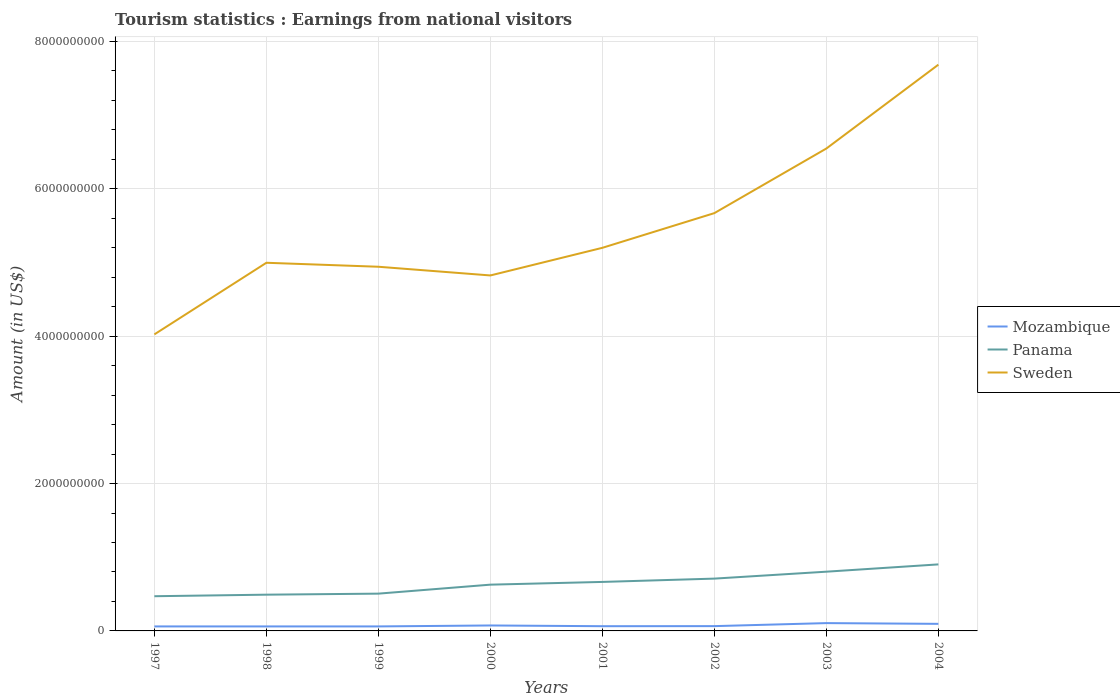Across all years, what is the maximum earnings from national visitors in Sweden?
Provide a short and direct response. 4.02e+09. In which year was the earnings from national visitors in Mozambique maximum?
Offer a terse response. 1997. What is the total earnings from national visitors in Sweden in the graph?
Your response must be concise. -8.46e+08. What is the difference between the highest and the second highest earnings from national visitors in Sweden?
Ensure brevity in your answer.  3.66e+09. What is the difference between the highest and the lowest earnings from national visitors in Mozambique?
Offer a very short reply. 3. How many lines are there?
Offer a very short reply. 3. How many years are there in the graph?
Offer a terse response. 8. Are the values on the major ticks of Y-axis written in scientific E-notation?
Provide a succinct answer. No. Does the graph contain grids?
Offer a terse response. Yes. Where does the legend appear in the graph?
Provide a short and direct response. Center right. How many legend labels are there?
Make the answer very short. 3. What is the title of the graph?
Your answer should be compact. Tourism statistics : Earnings from national visitors. What is the label or title of the Y-axis?
Provide a short and direct response. Amount (in US$). What is the Amount (in US$) in Mozambique in 1997?
Provide a short and direct response. 6.10e+07. What is the Amount (in US$) in Panama in 1997?
Your answer should be compact. 4.71e+08. What is the Amount (in US$) of Sweden in 1997?
Your answer should be very brief. 4.02e+09. What is the Amount (in US$) of Mozambique in 1998?
Provide a short and direct response. 6.10e+07. What is the Amount (in US$) of Panama in 1998?
Keep it short and to the point. 4.92e+08. What is the Amount (in US$) in Sweden in 1998?
Provide a short and direct response. 5.00e+09. What is the Amount (in US$) of Mozambique in 1999?
Provide a short and direct response. 6.10e+07. What is the Amount (in US$) in Panama in 1999?
Give a very brief answer. 5.06e+08. What is the Amount (in US$) of Sweden in 1999?
Provide a succinct answer. 4.94e+09. What is the Amount (in US$) in Mozambique in 2000?
Keep it short and to the point. 7.40e+07. What is the Amount (in US$) of Panama in 2000?
Your answer should be compact. 6.28e+08. What is the Amount (in US$) of Sweden in 2000?
Offer a terse response. 4.82e+09. What is the Amount (in US$) in Mozambique in 2001?
Make the answer very short. 6.40e+07. What is the Amount (in US$) of Panama in 2001?
Give a very brief answer. 6.65e+08. What is the Amount (in US$) of Sweden in 2001?
Offer a terse response. 5.20e+09. What is the Amount (in US$) in Mozambique in 2002?
Your answer should be very brief. 6.50e+07. What is the Amount (in US$) of Panama in 2002?
Your answer should be very brief. 7.10e+08. What is the Amount (in US$) in Sweden in 2002?
Your answer should be very brief. 5.67e+09. What is the Amount (in US$) in Mozambique in 2003?
Offer a very short reply. 1.06e+08. What is the Amount (in US$) of Panama in 2003?
Your answer should be compact. 8.04e+08. What is the Amount (in US$) in Sweden in 2003?
Your response must be concise. 6.55e+09. What is the Amount (in US$) in Mozambique in 2004?
Your response must be concise. 9.60e+07. What is the Amount (in US$) of Panama in 2004?
Offer a terse response. 9.03e+08. What is the Amount (in US$) in Sweden in 2004?
Give a very brief answer. 7.69e+09. Across all years, what is the maximum Amount (in US$) in Mozambique?
Offer a very short reply. 1.06e+08. Across all years, what is the maximum Amount (in US$) in Panama?
Your response must be concise. 9.03e+08. Across all years, what is the maximum Amount (in US$) of Sweden?
Your response must be concise. 7.69e+09. Across all years, what is the minimum Amount (in US$) of Mozambique?
Keep it short and to the point. 6.10e+07. Across all years, what is the minimum Amount (in US$) of Panama?
Make the answer very short. 4.71e+08. Across all years, what is the minimum Amount (in US$) in Sweden?
Keep it short and to the point. 4.02e+09. What is the total Amount (in US$) in Mozambique in the graph?
Your response must be concise. 5.88e+08. What is the total Amount (in US$) in Panama in the graph?
Ensure brevity in your answer.  5.18e+09. What is the total Amount (in US$) of Sweden in the graph?
Make the answer very short. 4.39e+1. What is the difference between the Amount (in US$) in Panama in 1997 and that in 1998?
Keep it short and to the point. -2.10e+07. What is the difference between the Amount (in US$) of Sweden in 1997 and that in 1998?
Ensure brevity in your answer.  -9.72e+08. What is the difference between the Amount (in US$) in Mozambique in 1997 and that in 1999?
Offer a terse response. 0. What is the difference between the Amount (in US$) of Panama in 1997 and that in 1999?
Make the answer very short. -3.50e+07. What is the difference between the Amount (in US$) in Sweden in 1997 and that in 1999?
Offer a very short reply. -9.18e+08. What is the difference between the Amount (in US$) of Mozambique in 1997 and that in 2000?
Keep it short and to the point. -1.30e+07. What is the difference between the Amount (in US$) in Panama in 1997 and that in 2000?
Give a very brief answer. -1.57e+08. What is the difference between the Amount (in US$) in Sweden in 1997 and that in 2000?
Give a very brief answer. -8.00e+08. What is the difference between the Amount (in US$) in Panama in 1997 and that in 2001?
Your response must be concise. -1.94e+08. What is the difference between the Amount (in US$) in Sweden in 1997 and that in 2001?
Make the answer very short. -1.18e+09. What is the difference between the Amount (in US$) of Mozambique in 1997 and that in 2002?
Give a very brief answer. -4.00e+06. What is the difference between the Amount (in US$) in Panama in 1997 and that in 2002?
Ensure brevity in your answer.  -2.39e+08. What is the difference between the Amount (in US$) of Sweden in 1997 and that in 2002?
Your response must be concise. -1.65e+09. What is the difference between the Amount (in US$) in Mozambique in 1997 and that in 2003?
Offer a very short reply. -4.50e+07. What is the difference between the Amount (in US$) of Panama in 1997 and that in 2003?
Your answer should be very brief. -3.33e+08. What is the difference between the Amount (in US$) in Sweden in 1997 and that in 2003?
Your response must be concise. -2.52e+09. What is the difference between the Amount (in US$) of Mozambique in 1997 and that in 2004?
Keep it short and to the point. -3.50e+07. What is the difference between the Amount (in US$) of Panama in 1997 and that in 2004?
Keep it short and to the point. -4.32e+08. What is the difference between the Amount (in US$) in Sweden in 1997 and that in 2004?
Your answer should be very brief. -3.66e+09. What is the difference between the Amount (in US$) in Panama in 1998 and that in 1999?
Your response must be concise. -1.40e+07. What is the difference between the Amount (in US$) of Sweden in 1998 and that in 1999?
Keep it short and to the point. 5.40e+07. What is the difference between the Amount (in US$) in Mozambique in 1998 and that in 2000?
Ensure brevity in your answer.  -1.30e+07. What is the difference between the Amount (in US$) in Panama in 1998 and that in 2000?
Provide a succinct answer. -1.36e+08. What is the difference between the Amount (in US$) of Sweden in 1998 and that in 2000?
Your answer should be compact. 1.72e+08. What is the difference between the Amount (in US$) of Mozambique in 1998 and that in 2001?
Provide a succinct answer. -3.00e+06. What is the difference between the Amount (in US$) in Panama in 1998 and that in 2001?
Your answer should be very brief. -1.73e+08. What is the difference between the Amount (in US$) of Sweden in 1998 and that in 2001?
Your answer should be compact. -2.03e+08. What is the difference between the Amount (in US$) in Panama in 1998 and that in 2002?
Your answer should be compact. -2.18e+08. What is the difference between the Amount (in US$) in Sweden in 1998 and that in 2002?
Ensure brevity in your answer.  -6.74e+08. What is the difference between the Amount (in US$) in Mozambique in 1998 and that in 2003?
Keep it short and to the point. -4.50e+07. What is the difference between the Amount (in US$) in Panama in 1998 and that in 2003?
Make the answer very short. -3.12e+08. What is the difference between the Amount (in US$) of Sweden in 1998 and that in 2003?
Offer a very short reply. -1.55e+09. What is the difference between the Amount (in US$) in Mozambique in 1998 and that in 2004?
Offer a terse response. -3.50e+07. What is the difference between the Amount (in US$) in Panama in 1998 and that in 2004?
Your response must be concise. -4.11e+08. What is the difference between the Amount (in US$) of Sweden in 1998 and that in 2004?
Your response must be concise. -2.69e+09. What is the difference between the Amount (in US$) of Mozambique in 1999 and that in 2000?
Provide a succinct answer. -1.30e+07. What is the difference between the Amount (in US$) of Panama in 1999 and that in 2000?
Provide a short and direct response. -1.22e+08. What is the difference between the Amount (in US$) of Sweden in 1999 and that in 2000?
Your answer should be compact. 1.18e+08. What is the difference between the Amount (in US$) of Mozambique in 1999 and that in 2001?
Make the answer very short. -3.00e+06. What is the difference between the Amount (in US$) in Panama in 1999 and that in 2001?
Your response must be concise. -1.59e+08. What is the difference between the Amount (in US$) of Sweden in 1999 and that in 2001?
Keep it short and to the point. -2.57e+08. What is the difference between the Amount (in US$) in Mozambique in 1999 and that in 2002?
Your response must be concise. -4.00e+06. What is the difference between the Amount (in US$) in Panama in 1999 and that in 2002?
Your response must be concise. -2.04e+08. What is the difference between the Amount (in US$) of Sweden in 1999 and that in 2002?
Make the answer very short. -7.28e+08. What is the difference between the Amount (in US$) of Mozambique in 1999 and that in 2003?
Offer a very short reply. -4.50e+07. What is the difference between the Amount (in US$) of Panama in 1999 and that in 2003?
Provide a short and direct response. -2.98e+08. What is the difference between the Amount (in US$) in Sweden in 1999 and that in 2003?
Your answer should be very brief. -1.60e+09. What is the difference between the Amount (in US$) in Mozambique in 1999 and that in 2004?
Provide a succinct answer. -3.50e+07. What is the difference between the Amount (in US$) of Panama in 1999 and that in 2004?
Make the answer very short. -3.97e+08. What is the difference between the Amount (in US$) of Sweden in 1999 and that in 2004?
Provide a succinct answer. -2.74e+09. What is the difference between the Amount (in US$) in Mozambique in 2000 and that in 2001?
Offer a very short reply. 1.00e+07. What is the difference between the Amount (in US$) in Panama in 2000 and that in 2001?
Give a very brief answer. -3.70e+07. What is the difference between the Amount (in US$) of Sweden in 2000 and that in 2001?
Keep it short and to the point. -3.75e+08. What is the difference between the Amount (in US$) in Mozambique in 2000 and that in 2002?
Provide a short and direct response. 9.00e+06. What is the difference between the Amount (in US$) of Panama in 2000 and that in 2002?
Keep it short and to the point. -8.20e+07. What is the difference between the Amount (in US$) in Sweden in 2000 and that in 2002?
Your answer should be compact. -8.46e+08. What is the difference between the Amount (in US$) in Mozambique in 2000 and that in 2003?
Offer a terse response. -3.20e+07. What is the difference between the Amount (in US$) of Panama in 2000 and that in 2003?
Your response must be concise. -1.76e+08. What is the difference between the Amount (in US$) in Sweden in 2000 and that in 2003?
Keep it short and to the point. -1.72e+09. What is the difference between the Amount (in US$) of Mozambique in 2000 and that in 2004?
Ensure brevity in your answer.  -2.20e+07. What is the difference between the Amount (in US$) of Panama in 2000 and that in 2004?
Offer a terse response. -2.75e+08. What is the difference between the Amount (in US$) of Sweden in 2000 and that in 2004?
Provide a succinct answer. -2.86e+09. What is the difference between the Amount (in US$) of Mozambique in 2001 and that in 2002?
Offer a very short reply. -1.00e+06. What is the difference between the Amount (in US$) of Panama in 2001 and that in 2002?
Your answer should be very brief. -4.50e+07. What is the difference between the Amount (in US$) of Sweden in 2001 and that in 2002?
Give a very brief answer. -4.71e+08. What is the difference between the Amount (in US$) in Mozambique in 2001 and that in 2003?
Ensure brevity in your answer.  -4.20e+07. What is the difference between the Amount (in US$) in Panama in 2001 and that in 2003?
Your answer should be very brief. -1.39e+08. What is the difference between the Amount (in US$) in Sweden in 2001 and that in 2003?
Your answer should be very brief. -1.35e+09. What is the difference between the Amount (in US$) in Mozambique in 2001 and that in 2004?
Offer a terse response. -3.20e+07. What is the difference between the Amount (in US$) in Panama in 2001 and that in 2004?
Your answer should be very brief. -2.38e+08. What is the difference between the Amount (in US$) of Sweden in 2001 and that in 2004?
Provide a short and direct response. -2.49e+09. What is the difference between the Amount (in US$) in Mozambique in 2002 and that in 2003?
Ensure brevity in your answer.  -4.10e+07. What is the difference between the Amount (in US$) in Panama in 2002 and that in 2003?
Offer a terse response. -9.40e+07. What is the difference between the Amount (in US$) in Sweden in 2002 and that in 2003?
Offer a very short reply. -8.77e+08. What is the difference between the Amount (in US$) in Mozambique in 2002 and that in 2004?
Your answer should be compact. -3.10e+07. What is the difference between the Amount (in US$) in Panama in 2002 and that in 2004?
Provide a succinct answer. -1.93e+08. What is the difference between the Amount (in US$) of Sweden in 2002 and that in 2004?
Offer a terse response. -2.02e+09. What is the difference between the Amount (in US$) in Mozambique in 2003 and that in 2004?
Provide a short and direct response. 1.00e+07. What is the difference between the Amount (in US$) in Panama in 2003 and that in 2004?
Your answer should be very brief. -9.90e+07. What is the difference between the Amount (in US$) in Sweden in 2003 and that in 2004?
Your answer should be very brief. -1.14e+09. What is the difference between the Amount (in US$) of Mozambique in 1997 and the Amount (in US$) of Panama in 1998?
Offer a terse response. -4.31e+08. What is the difference between the Amount (in US$) of Mozambique in 1997 and the Amount (in US$) of Sweden in 1998?
Your response must be concise. -4.94e+09. What is the difference between the Amount (in US$) in Panama in 1997 and the Amount (in US$) in Sweden in 1998?
Your answer should be compact. -4.53e+09. What is the difference between the Amount (in US$) in Mozambique in 1997 and the Amount (in US$) in Panama in 1999?
Offer a very short reply. -4.45e+08. What is the difference between the Amount (in US$) of Mozambique in 1997 and the Amount (in US$) of Sweden in 1999?
Provide a short and direct response. -4.88e+09. What is the difference between the Amount (in US$) in Panama in 1997 and the Amount (in US$) in Sweden in 1999?
Your answer should be compact. -4.47e+09. What is the difference between the Amount (in US$) in Mozambique in 1997 and the Amount (in US$) in Panama in 2000?
Give a very brief answer. -5.67e+08. What is the difference between the Amount (in US$) in Mozambique in 1997 and the Amount (in US$) in Sweden in 2000?
Your response must be concise. -4.76e+09. What is the difference between the Amount (in US$) in Panama in 1997 and the Amount (in US$) in Sweden in 2000?
Keep it short and to the point. -4.35e+09. What is the difference between the Amount (in US$) of Mozambique in 1997 and the Amount (in US$) of Panama in 2001?
Your answer should be compact. -6.04e+08. What is the difference between the Amount (in US$) in Mozambique in 1997 and the Amount (in US$) in Sweden in 2001?
Ensure brevity in your answer.  -5.14e+09. What is the difference between the Amount (in US$) in Panama in 1997 and the Amount (in US$) in Sweden in 2001?
Your response must be concise. -4.73e+09. What is the difference between the Amount (in US$) in Mozambique in 1997 and the Amount (in US$) in Panama in 2002?
Your answer should be compact. -6.49e+08. What is the difference between the Amount (in US$) in Mozambique in 1997 and the Amount (in US$) in Sweden in 2002?
Keep it short and to the point. -5.61e+09. What is the difference between the Amount (in US$) in Panama in 1997 and the Amount (in US$) in Sweden in 2002?
Make the answer very short. -5.20e+09. What is the difference between the Amount (in US$) in Mozambique in 1997 and the Amount (in US$) in Panama in 2003?
Make the answer very short. -7.43e+08. What is the difference between the Amount (in US$) in Mozambique in 1997 and the Amount (in US$) in Sweden in 2003?
Keep it short and to the point. -6.49e+09. What is the difference between the Amount (in US$) in Panama in 1997 and the Amount (in US$) in Sweden in 2003?
Offer a very short reply. -6.08e+09. What is the difference between the Amount (in US$) of Mozambique in 1997 and the Amount (in US$) of Panama in 2004?
Provide a short and direct response. -8.42e+08. What is the difference between the Amount (in US$) of Mozambique in 1997 and the Amount (in US$) of Sweden in 2004?
Offer a terse response. -7.62e+09. What is the difference between the Amount (in US$) of Panama in 1997 and the Amount (in US$) of Sweden in 2004?
Your answer should be compact. -7.22e+09. What is the difference between the Amount (in US$) of Mozambique in 1998 and the Amount (in US$) of Panama in 1999?
Ensure brevity in your answer.  -4.45e+08. What is the difference between the Amount (in US$) in Mozambique in 1998 and the Amount (in US$) in Sweden in 1999?
Give a very brief answer. -4.88e+09. What is the difference between the Amount (in US$) in Panama in 1998 and the Amount (in US$) in Sweden in 1999?
Offer a terse response. -4.45e+09. What is the difference between the Amount (in US$) in Mozambique in 1998 and the Amount (in US$) in Panama in 2000?
Your answer should be very brief. -5.67e+08. What is the difference between the Amount (in US$) of Mozambique in 1998 and the Amount (in US$) of Sweden in 2000?
Your answer should be very brief. -4.76e+09. What is the difference between the Amount (in US$) in Panama in 1998 and the Amount (in US$) in Sweden in 2000?
Provide a succinct answer. -4.33e+09. What is the difference between the Amount (in US$) of Mozambique in 1998 and the Amount (in US$) of Panama in 2001?
Give a very brief answer. -6.04e+08. What is the difference between the Amount (in US$) of Mozambique in 1998 and the Amount (in US$) of Sweden in 2001?
Ensure brevity in your answer.  -5.14e+09. What is the difference between the Amount (in US$) of Panama in 1998 and the Amount (in US$) of Sweden in 2001?
Offer a terse response. -4.71e+09. What is the difference between the Amount (in US$) of Mozambique in 1998 and the Amount (in US$) of Panama in 2002?
Give a very brief answer. -6.49e+08. What is the difference between the Amount (in US$) of Mozambique in 1998 and the Amount (in US$) of Sweden in 2002?
Give a very brief answer. -5.61e+09. What is the difference between the Amount (in US$) in Panama in 1998 and the Amount (in US$) in Sweden in 2002?
Provide a succinct answer. -5.18e+09. What is the difference between the Amount (in US$) in Mozambique in 1998 and the Amount (in US$) in Panama in 2003?
Your answer should be very brief. -7.43e+08. What is the difference between the Amount (in US$) in Mozambique in 1998 and the Amount (in US$) in Sweden in 2003?
Your answer should be compact. -6.49e+09. What is the difference between the Amount (in US$) of Panama in 1998 and the Amount (in US$) of Sweden in 2003?
Make the answer very short. -6.06e+09. What is the difference between the Amount (in US$) in Mozambique in 1998 and the Amount (in US$) in Panama in 2004?
Provide a short and direct response. -8.42e+08. What is the difference between the Amount (in US$) in Mozambique in 1998 and the Amount (in US$) in Sweden in 2004?
Give a very brief answer. -7.62e+09. What is the difference between the Amount (in US$) of Panama in 1998 and the Amount (in US$) of Sweden in 2004?
Provide a succinct answer. -7.19e+09. What is the difference between the Amount (in US$) of Mozambique in 1999 and the Amount (in US$) of Panama in 2000?
Make the answer very short. -5.67e+08. What is the difference between the Amount (in US$) of Mozambique in 1999 and the Amount (in US$) of Sweden in 2000?
Your answer should be compact. -4.76e+09. What is the difference between the Amount (in US$) of Panama in 1999 and the Amount (in US$) of Sweden in 2000?
Your response must be concise. -4.32e+09. What is the difference between the Amount (in US$) in Mozambique in 1999 and the Amount (in US$) in Panama in 2001?
Keep it short and to the point. -6.04e+08. What is the difference between the Amount (in US$) of Mozambique in 1999 and the Amount (in US$) of Sweden in 2001?
Offer a terse response. -5.14e+09. What is the difference between the Amount (in US$) in Panama in 1999 and the Amount (in US$) in Sweden in 2001?
Make the answer very short. -4.69e+09. What is the difference between the Amount (in US$) in Mozambique in 1999 and the Amount (in US$) in Panama in 2002?
Offer a very short reply. -6.49e+08. What is the difference between the Amount (in US$) in Mozambique in 1999 and the Amount (in US$) in Sweden in 2002?
Ensure brevity in your answer.  -5.61e+09. What is the difference between the Amount (in US$) in Panama in 1999 and the Amount (in US$) in Sweden in 2002?
Your answer should be very brief. -5.16e+09. What is the difference between the Amount (in US$) of Mozambique in 1999 and the Amount (in US$) of Panama in 2003?
Offer a terse response. -7.43e+08. What is the difference between the Amount (in US$) of Mozambique in 1999 and the Amount (in US$) of Sweden in 2003?
Keep it short and to the point. -6.49e+09. What is the difference between the Amount (in US$) of Panama in 1999 and the Amount (in US$) of Sweden in 2003?
Ensure brevity in your answer.  -6.04e+09. What is the difference between the Amount (in US$) of Mozambique in 1999 and the Amount (in US$) of Panama in 2004?
Your answer should be compact. -8.42e+08. What is the difference between the Amount (in US$) of Mozambique in 1999 and the Amount (in US$) of Sweden in 2004?
Ensure brevity in your answer.  -7.62e+09. What is the difference between the Amount (in US$) of Panama in 1999 and the Amount (in US$) of Sweden in 2004?
Keep it short and to the point. -7.18e+09. What is the difference between the Amount (in US$) of Mozambique in 2000 and the Amount (in US$) of Panama in 2001?
Make the answer very short. -5.91e+08. What is the difference between the Amount (in US$) of Mozambique in 2000 and the Amount (in US$) of Sweden in 2001?
Your answer should be compact. -5.13e+09. What is the difference between the Amount (in US$) of Panama in 2000 and the Amount (in US$) of Sweden in 2001?
Give a very brief answer. -4.57e+09. What is the difference between the Amount (in US$) in Mozambique in 2000 and the Amount (in US$) in Panama in 2002?
Your answer should be very brief. -6.36e+08. What is the difference between the Amount (in US$) in Mozambique in 2000 and the Amount (in US$) in Sweden in 2002?
Keep it short and to the point. -5.60e+09. What is the difference between the Amount (in US$) in Panama in 2000 and the Amount (in US$) in Sweden in 2002?
Give a very brief answer. -5.04e+09. What is the difference between the Amount (in US$) of Mozambique in 2000 and the Amount (in US$) of Panama in 2003?
Offer a terse response. -7.30e+08. What is the difference between the Amount (in US$) in Mozambique in 2000 and the Amount (in US$) in Sweden in 2003?
Give a very brief answer. -6.47e+09. What is the difference between the Amount (in US$) in Panama in 2000 and the Amount (in US$) in Sweden in 2003?
Keep it short and to the point. -5.92e+09. What is the difference between the Amount (in US$) in Mozambique in 2000 and the Amount (in US$) in Panama in 2004?
Offer a very short reply. -8.29e+08. What is the difference between the Amount (in US$) in Mozambique in 2000 and the Amount (in US$) in Sweden in 2004?
Provide a succinct answer. -7.61e+09. What is the difference between the Amount (in US$) in Panama in 2000 and the Amount (in US$) in Sweden in 2004?
Your answer should be compact. -7.06e+09. What is the difference between the Amount (in US$) of Mozambique in 2001 and the Amount (in US$) of Panama in 2002?
Your response must be concise. -6.46e+08. What is the difference between the Amount (in US$) in Mozambique in 2001 and the Amount (in US$) in Sweden in 2002?
Offer a very short reply. -5.61e+09. What is the difference between the Amount (in US$) of Panama in 2001 and the Amount (in US$) of Sweden in 2002?
Provide a succinct answer. -5.01e+09. What is the difference between the Amount (in US$) in Mozambique in 2001 and the Amount (in US$) in Panama in 2003?
Keep it short and to the point. -7.40e+08. What is the difference between the Amount (in US$) in Mozambique in 2001 and the Amount (in US$) in Sweden in 2003?
Offer a terse response. -6.48e+09. What is the difference between the Amount (in US$) in Panama in 2001 and the Amount (in US$) in Sweden in 2003?
Keep it short and to the point. -5.88e+09. What is the difference between the Amount (in US$) in Mozambique in 2001 and the Amount (in US$) in Panama in 2004?
Your answer should be very brief. -8.39e+08. What is the difference between the Amount (in US$) in Mozambique in 2001 and the Amount (in US$) in Sweden in 2004?
Make the answer very short. -7.62e+09. What is the difference between the Amount (in US$) of Panama in 2001 and the Amount (in US$) of Sweden in 2004?
Offer a very short reply. -7.02e+09. What is the difference between the Amount (in US$) of Mozambique in 2002 and the Amount (in US$) of Panama in 2003?
Keep it short and to the point. -7.39e+08. What is the difference between the Amount (in US$) in Mozambique in 2002 and the Amount (in US$) in Sweden in 2003?
Ensure brevity in your answer.  -6.48e+09. What is the difference between the Amount (in US$) in Panama in 2002 and the Amount (in US$) in Sweden in 2003?
Your answer should be compact. -5.84e+09. What is the difference between the Amount (in US$) of Mozambique in 2002 and the Amount (in US$) of Panama in 2004?
Provide a succinct answer. -8.38e+08. What is the difference between the Amount (in US$) in Mozambique in 2002 and the Amount (in US$) in Sweden in 2004?
Provide a succinct answer. -7.62e+09. What is the difference between the Amount (in US$) of Panama in 2002 and the Amount (in US$) of Sweden in 2004?
Ensure brevity in your answer.  -6.98e+09. What is the difference between the Amount (in US$) of Mozambique in 2003 and the Amount (in US$) of Panama in 2004?
Offer a terse response. -7.97e+08. What is the difference between the Amount (in US$) in Mozambique in 2003 and the Amount (in US$) in Sweden in 2004?
Provide a succinct answer. -7.58e+09. What is the difference between the Amount (in US$) of Panama in 2003 and the Amount (in US$) of Sweden in 2004?
Keep it short and to the point. -6.88e+09. What is the average Amount (in US$) of Mozambique per year?
Your answer should be very brief. 7.35e+07. What is the average Amount (in US$) of Panama per year?
Ensure brevity in your answer.  6.47e+08. What is the average Amount (in US$) in Sweden per year?
Provide a succinct answer. 5.49e+09. In the year 1997, what is the difference between the Amount (in US$) of Mozambique and Amount (in US$) of Panama?
Provide a short and direct response. -4.10e+08. In the year 1997, what is the difference between the Amount (in US$) in Mozambique and Amount (in US$) in Sweden?
Offer a terse response. -3.96e+09. In the year 1997, what is the difference between the Amount (in US$) in Panama and Amount (in US$) in Sweden?
Make the answer very short. -3.55e+09. In the year 1998, what is the difference between the Amount (in US$) of Mozambique and Amount (in US$) of Panama?
Your response must be concise. -4.31e+08. In the year 1998, what is the difference between the Amount (in US$) in Mozambique and Amount (in US$) in Sweden?
Your answer should be compact. -4.94e+09. In the year 1998, what is the difference between the Amount (in US$) in Panama and Amount (in US$) in Sweden?
Ensure brevity in your answer.  -4.50e+09. In the year 1999, what is the difference between the Amount (in US$) in Mozambique and Amount (in US$) in Panama?
Offer a very short reply. -4.45e+08. In the year 1999, what is the difference between the Amount (in US$) of Mozambique and Amount (in US$) of Sweden?
Offer a terse response. -4.88e+09. In the year 1999, what is the difference between the Amount (in US$) of Panama and Amount (in US$) of Sweden?
Ensure brevity in your answer.  -4.44e+09. In the year 2000, what is the difference between the Amount (in US$) of Mozambique and Amount (in US$) of Panama?
Your answer should be very brief. -5.54e+08. In the year 2000, what is the difference between the Amount (in US$) of Mozambique and Amount (in US$) of Sweden?
Your answer should be compact. -4.75e+09. In the year 2000, what is the difference between the Amount (in US$) in Panama and Amount (in US$) in Sweden?
Keep it short and to the point. -4.20e+09. In the year 2001, what is the difference between the Amount (in US$) of Mozambique and Amount (in US$) of Panama?
Make the answer very short. -6.01e+08. In the year 2001, what is the difference between the Amount (in US$) in Mozambique and Amount (in US$) in Sweden?
Offer a very short reply. -5.14e+09. In the year 2001, what is the difference between the Amount (in US$) of Panama and Amount (in US$) of Sweden?
Your response must be concise. -4.54e+09. In the year 2002, what is the difference between the Amount (in US$) in Mozambique and Amount (in US$) in Panama?
Offer a very short reply. -6.45e+08. In the year 2002, what is the difference between the Amount (in US$) in Mozambique and Amount (in US$) in Sweden?
Give a very brief answer. -5.61e+09. In the year 2002, what is the difference between the Amount (in US$) of Panama and Amount (in US$) of Sweden?
Provide a succinct answer. -4.96e+09. In the year 2003, what is the difference between the Amount (in US$) in Mozambique and Amount (in US$) in Panama?
Provide a succinct answer. -6.98e+08. In the year 2003, what is the difference between the Amount (in US$) in Mozambique and Amount (in US$) in Sweden?
Provide a succinct answer. -6.44e+09. In the year 2003, what is the difference between the Amount (in US$) of Panama and Amount (in US$) of Sweden?
Your answer should be very brief. -5.74e+09. In the year 2004, what is the difference between the Amount (in US$) of Mozambique and Amount (in US$) of Panama?
Ensure brevity in your answer.  -8.07e+08. In the year 2004, what is the difference between the Amount (in US$) of Mozambique and Amount (in US$) of Sweden?
Your answer should be very brief. -7.59e+09. In the year 2004, what is the difference between the Amount (in US$) of Panama and Amount (in US$) of Sweden?
Provide a short and direct response. -6.78e+09. What is the ratio of the Amount (in US$) of Panama in 1997 to that in 1998?
Provide a short and direct response. 0.96. What is the ratio of the Amount (in US$) in Sweden in 1997 to that in 1998?
Offer a very short reply. 0.81. What is the ratio of the Amount (in US$) of Mozambique in 1997 to that in 1999?
Keep it short and to the point. 1. What is the ratio of the Amount (in US$) of Panama in 1997 to that in 1999?
Ensure brevity in your answer.  0.93. What is the ratio of the Amount (in US$) of Sweden in 1997 to that in 1999?
Offer a very short reply. 0.81. What is the ratio of the Amount (in US$) of Mozambique in 1997 to that in 2000?
Your answer should be very brief. 0.82. What is the ratio of the Amount (in US$) in Panama in 1997 to that in 2000?
Offer a very short reply. 0.75. What is the ratio of the Amount (in US$) of Sweden in 1997 to that in 2000?
Your answer should be very brief. 0.83. What is the ratio of the Amount (in US$) of Mozambique in 1997 to that in 2001?
Provide a short and direct response. 0.95. What is the ratio of the Amount (in US$) in Panama in 1997 to that in 2001?
Keep it short and to the point. 0.71. What is the ratio of the Amount (in US$) in Sweden in 1997 to that in 2001?
Offer a terse response. 0.77. What is the ratio of the Amount (in US$) in Mozambique in 1997 to that in 2002?
Provide a succinct answer. 0.94. What is the ratio of the Amount (in US$) in Panama in 1997 to that in 2002?
Your answer should be very brief. 0.66. What is the ratio of the Amount (in US$) of Sweden in 1997 to that in 2002?
Your response must be concise. 0.71. What is the ratio of the Amount (in US$) of Mozambique in 1997 to that in 2003?
Make the answer very short. 0.58. What is the ratio of the Amount (in US$) of Panama in 1997 to that in 2003?
Keep it short and to the point. 0.59. What is the ratio of the Amount (in US$) in Sweden in 1997 to that in 2003?
Give a very brief answer. 0.61. What is the ratio of the Amount (in US$) of Mozambique in 1997 to that in 2004?
Offer a very short reply. 0.64. What is the ratio of the Amount (in US$) in Panama in 1997 to that in 2004?
Offer a very short reply. 0.52. What is the ratio of the Amount (in US$) of Sweden in 1997 to that in 2004?
Make the answer very short. 0.52. What is the ratio of the Amount (in US$) in Mozambique in 1998 to that in 1999?
Offer a very short reply. 1. What is the ratio of the Amount (in US$) of Panama in 1998 to that in 1999?
Make the answer very short. 0.97. What is the ratio of the Amount (in US$) in Sweden in 1998 to that in 1999?
Give a very brief answer. 1.01. What is the ratio of the Amount (in US$) in Mozambique in 1998 to that in 2000?
Your answer should be very brief. 0.82. What is the ratio of the Amount (in US$) in Panama in 1998 to that in 2000?
Your answer should be compact. 0.78. What is the ratio of the Amount (in US$) in Sweden in 1998 to that in 2000?
Provide a succinct answer. 1.04. What is the ratio of the Amount (in US$) of Mozambique in 1998 to that in 2001?
Your response must be concise. 0.95. What is the ratio of the Amount (in US$) of Panama in 1998 to that in 2001?
Ensure brevity in your answer.  0.74. What is the ratio of the Amount (in US$) of Mozambique in 1998 to that in 2002?
Ensure brevity in your answer.  0.94. What is the ratio of the Amount (in US$) in Panama in 1998 to that in 2002?
Your response must be concise. 0.69. What is the ratio of the Amount (in US$) of Sweden in 1998 to that in 2002?
Offer a very short reply. 0.88. What is the ratio of the Amount (in US$) of Mozambique in 1998 to that in 2003?
Offer a terse response. 0.58. What is the ratio of the Amount (in US$) in Panama in 1998 to that in 2003?
Your answer should be compact. 0.61. What is the ratio of the Amount (in US$) of Sweden in 1998 to that in 2003?
Your response must be concise. 0.76. What is the ratio of the Amount (in US$) in Mozambique in 1998 to that in 2004?
Make the answer very short. 0.64. What is the ratio of the Amount (in US$) in Panama in 1998 to that in 2004?
Your answer should be very brief. 0.54. What is the ratio of the Amount (in US$) of Sweden in 1998 to that in 2004?
Give a very brief answer. 0.65. What is the ratio of the Amount (in US$) of Mozambique in 1999 to that in 2000?
Offer a terse response. 0.82. What is the ratio of the Amount (in US$) of Panama in 1999 to that in 2000?
Offer a very short reply. 0.81. What is the ratio of the Amount (in US$) of Sweden in 1999 to that in 2000?
Offer a terse response. 1.02. What is the ratio of the Amount (in US$) in Mozambique in 1999 to that in 2001?
Provide a succinct answer. 0.95. What is the ratio of the Amount (in US$) in Panama in 1999 to that in 2001?
Make the answer very short. 0.76. What is the ratio of the Amount (in US$) in Sweden in 1999 to that in 2001?
Keep it short and to the point. 0.95. What is the ratio of the Amount (in US$) in Mozambique in 1999 to that in 2002?
Make the answer very short. 0.94. What is the ratio of the Amount (in US$) in Panama in 1999 to that in 2002?
Your answer should be compact. 0.71. What is the ratio of the Amount (in US$) in Sweden in 1999 to that in 2002?
Make the answer very short. 0.87. What is the ratio of the Amount (in US$) of Mozambique in 1999 to that in 2003?
Provide a succinct answer. 0.58. What is the ratio of the Amount (in US$) of Panama in 1999 to that in 2003?
Offer a very short reply. 0.63. What is the ratio of the Amount (in US$) in Sweden in 1999 to that in 2003?
Provide a short and direct response. 0.75. What is the ratio of the Amount (in US$) in Mozambique in 1999 to that in 2004?
Your answer should be compact. 0.64. What is the ratio of the Amount (in US$) of Panama in 1999 to that in 2004?
Your response must be concise. 0.56. What is the ratio of the Amount (in US$) in Sweden in 1999 to that in 2004?
Make the answer very short. 0.64. What is the ratio of the Amount (in US$) in Mozambique in 2000 to that in 2001?
Your answer should be compact. 1.16. What is the ratio of the Amount (in US$) of Panama in 2000 to that in 2001?
Give a very brief answer. 0.94. What is the ratio of the Amount (in US$) in Sweden in 2000 to that in 2001?
Give a very brief answer. 0.93. What is the ratio of the Amount (in US$) of Mozambique in 2000 to that in 2002?
Provide a succinct answer. 1.14. What is the ratio of the Amount (in US$) in Panama in 2000 to that in 2002?
Keep it short and to the point. 0.88. What is the ratio of the Amount (in US$) of Sweden in 2000 to that in 2002?
Offer a terse response. 0.85. What is the ratio of the Amount (in US$) in Mozambique in 2000 to that in 2003?
Make the answer very short. 0.7. What is the ratio of the Amount (in US$) of Panama in 2000 to that in 2003?
Make the answer very short. 0.78. What is the ratio of the Amount (in US$) of Sweden in 2000 to that in 2003?
Keep it short and to the point. 0.74. What is the ratio of the Amount (in US$) of Mozambique in 2000 to that in 2004?
Your answer should be compact. 0.77. What is the ratio of the Amount (in US$) of Panama in 2000 to that in 2004?
Keep it short and to the point. 0.7. What is the ratio of the Amount (in US$) of Sweden in 2000 to that in 2004?
Provide a succinct answer. 0.63. What is the ratio of the Amount (in US$) of Mozambique in 2001 to that in 2002?
Keep it short and to the point. 0.98. What is the ratio of the Amount (in US$) of Panama in 2001 to that in 2002?
Your answer should be compact. 0.94. What is the ratio of the Amount (in US$) of Sweden in 2001 to that in 2002?
Your response must be concise. 0.92. What is the ratio of the Amount (in US$) of Mozambique in 2001 to that in 2003?
Give a very brief answer. 0.6. What is the ratio of the Amount (in US$) of Panama in 2001 to that in 2003?
Your response must be concise. 0.83. What is the ratio of the Amount (in US$) of Sweden in 2001 to that in 2003?
Make the answer very short. 0.79. What is the ratio of the Amount (in US$) in Panama in 2001 to that in 2004?
Offer a terse response. 0.74. What is the ratio of the Amount (in US$) of Sweden in 2001 to that in 2004?
Make the answer very short. 0.68. What is the ratio of the Amount (in US$) of Mozambique in 2002 to that in 2003?
Provide a succinct answer. 0.61. What is the ratio of the Amount (in US$) in Panama in 2002 to that in 2003?
Your answer should be compact. 0.88. What is the ratio of the Amount (in US$) in Sweden in 2002 to that in 2003?
Offer a terse response. 0.87. What is the ratio of the Amount (in US$) in Mozambique in 2002 to that in 2004?
Your response must be concise. 0.68. What is the ratio of the Amount (in US$) of Panama in 2002 to that in 2004?
Offer a very short reply. 0.79. What is the ratio of the Amount (in US$) of Sweden in 2002 to that in 2004?
Provide a short and direct response. 0.74. What is the ratio of the Amount (in US$) in Mozambique in 2003 to that in 2004?
Give a very brief answer. 1.1. What is the ratio of the Amount (in US$) in Panama in 2003 to that in 2004?
Ensure brevity in your answer.  0.89. What is the ratio of the Amount (in US$) of Sweden in 2003 to that in 2004?
Your answer should be compact. 0.85. What is the difference between the highest and the second highest Amount (in US$) of Mozambique?
Provide a short and direct response. 1.00e+07. What is the difference between the highest and the second highest Amount (in US$) of Panama?
Provide a short and direct response. 9.90e+07. What is the difference between the highest and the second highest Amount (in US$) in Sweden?
Ensure brevity in your answer.  1.14e+09. What is the difference between the highest and the lowest Amount (in US$) in Mozambique?
Make the answer very short. 4.50e+07. What is the difference between the highest and the lowest Amount (in US$) of Panama?
Provide a short and direct response. 4.32e+08. What is the difference between the highest and the lowest Amount (in US$) in Sweden?
Offer a terse response. 3.66e+09. 